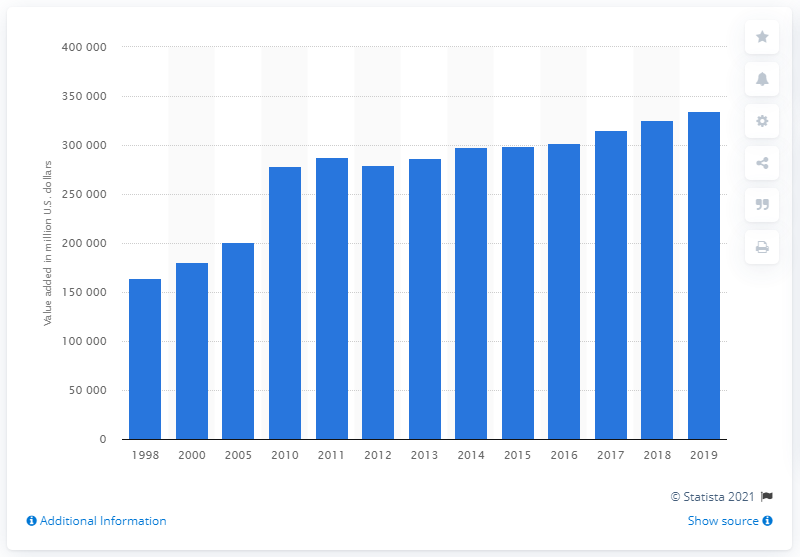Indicate a few pertinent items in this graphic. In 2019, the utility sector in the United States contributed significantly to the country's gross domestic product, equivalent to 334,634. 